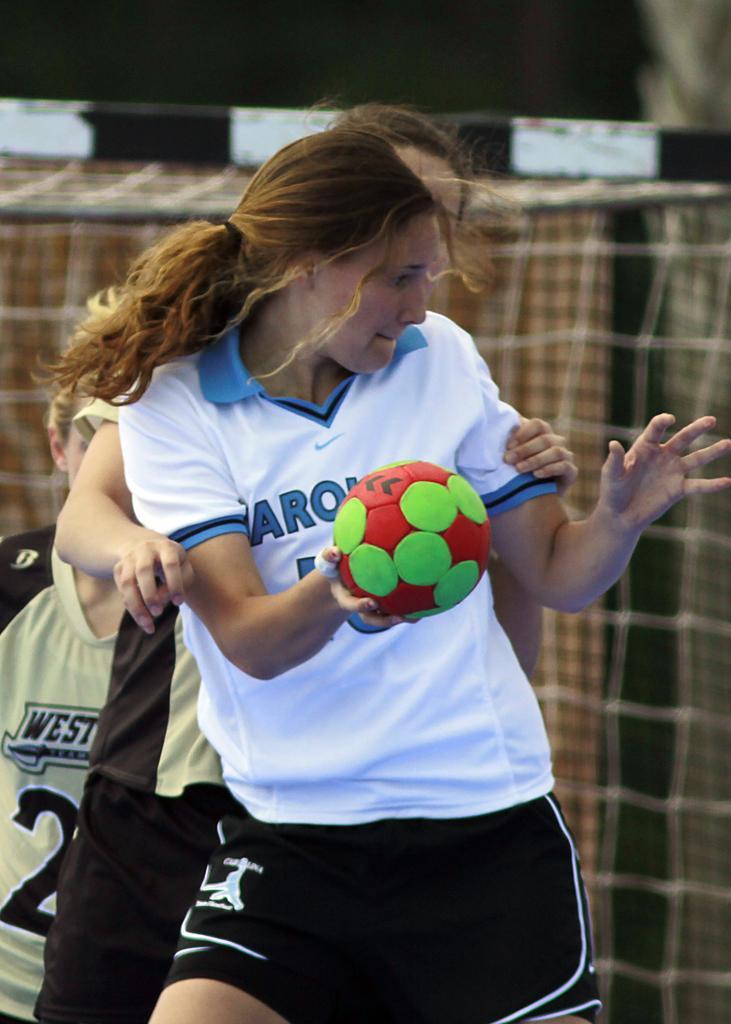Could you give a brief overview of what you see in this image? This image is clicked outside. In this three people they are playing some game ,the front one who is wearing white shirt is holding a ball. Behind her a woman is her and she is holding the girl who is in front of her. 